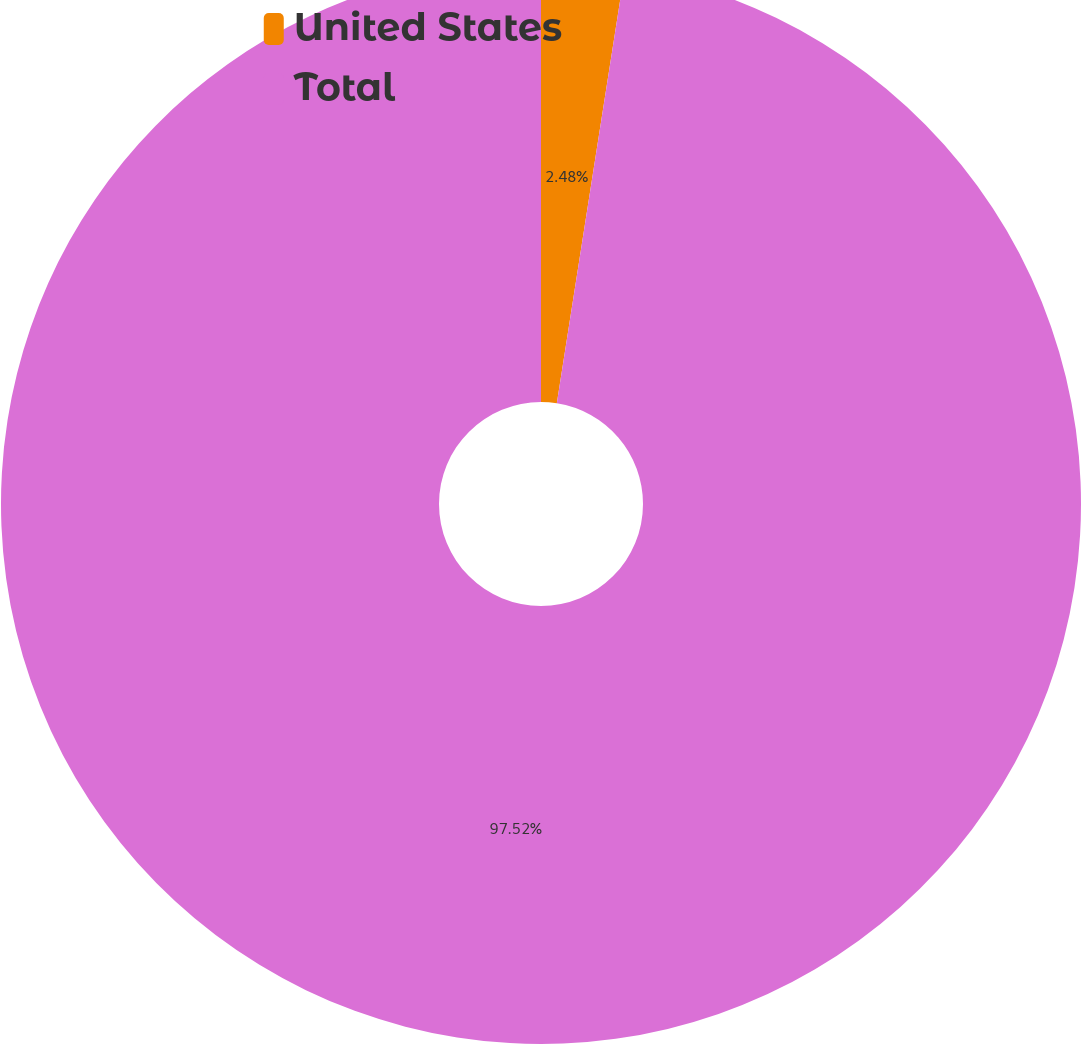<chart> <loc_0><loc_0><loc_500><loc_500><pie_chart><fcel>United States<fcel>Total<nl><fcel>2.48%<fcel>97.52%<nl></chart> 